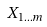<formula> <loc_0><loc_0><loc_500><loc_500>X _ { 1 \dots m }</formula> 